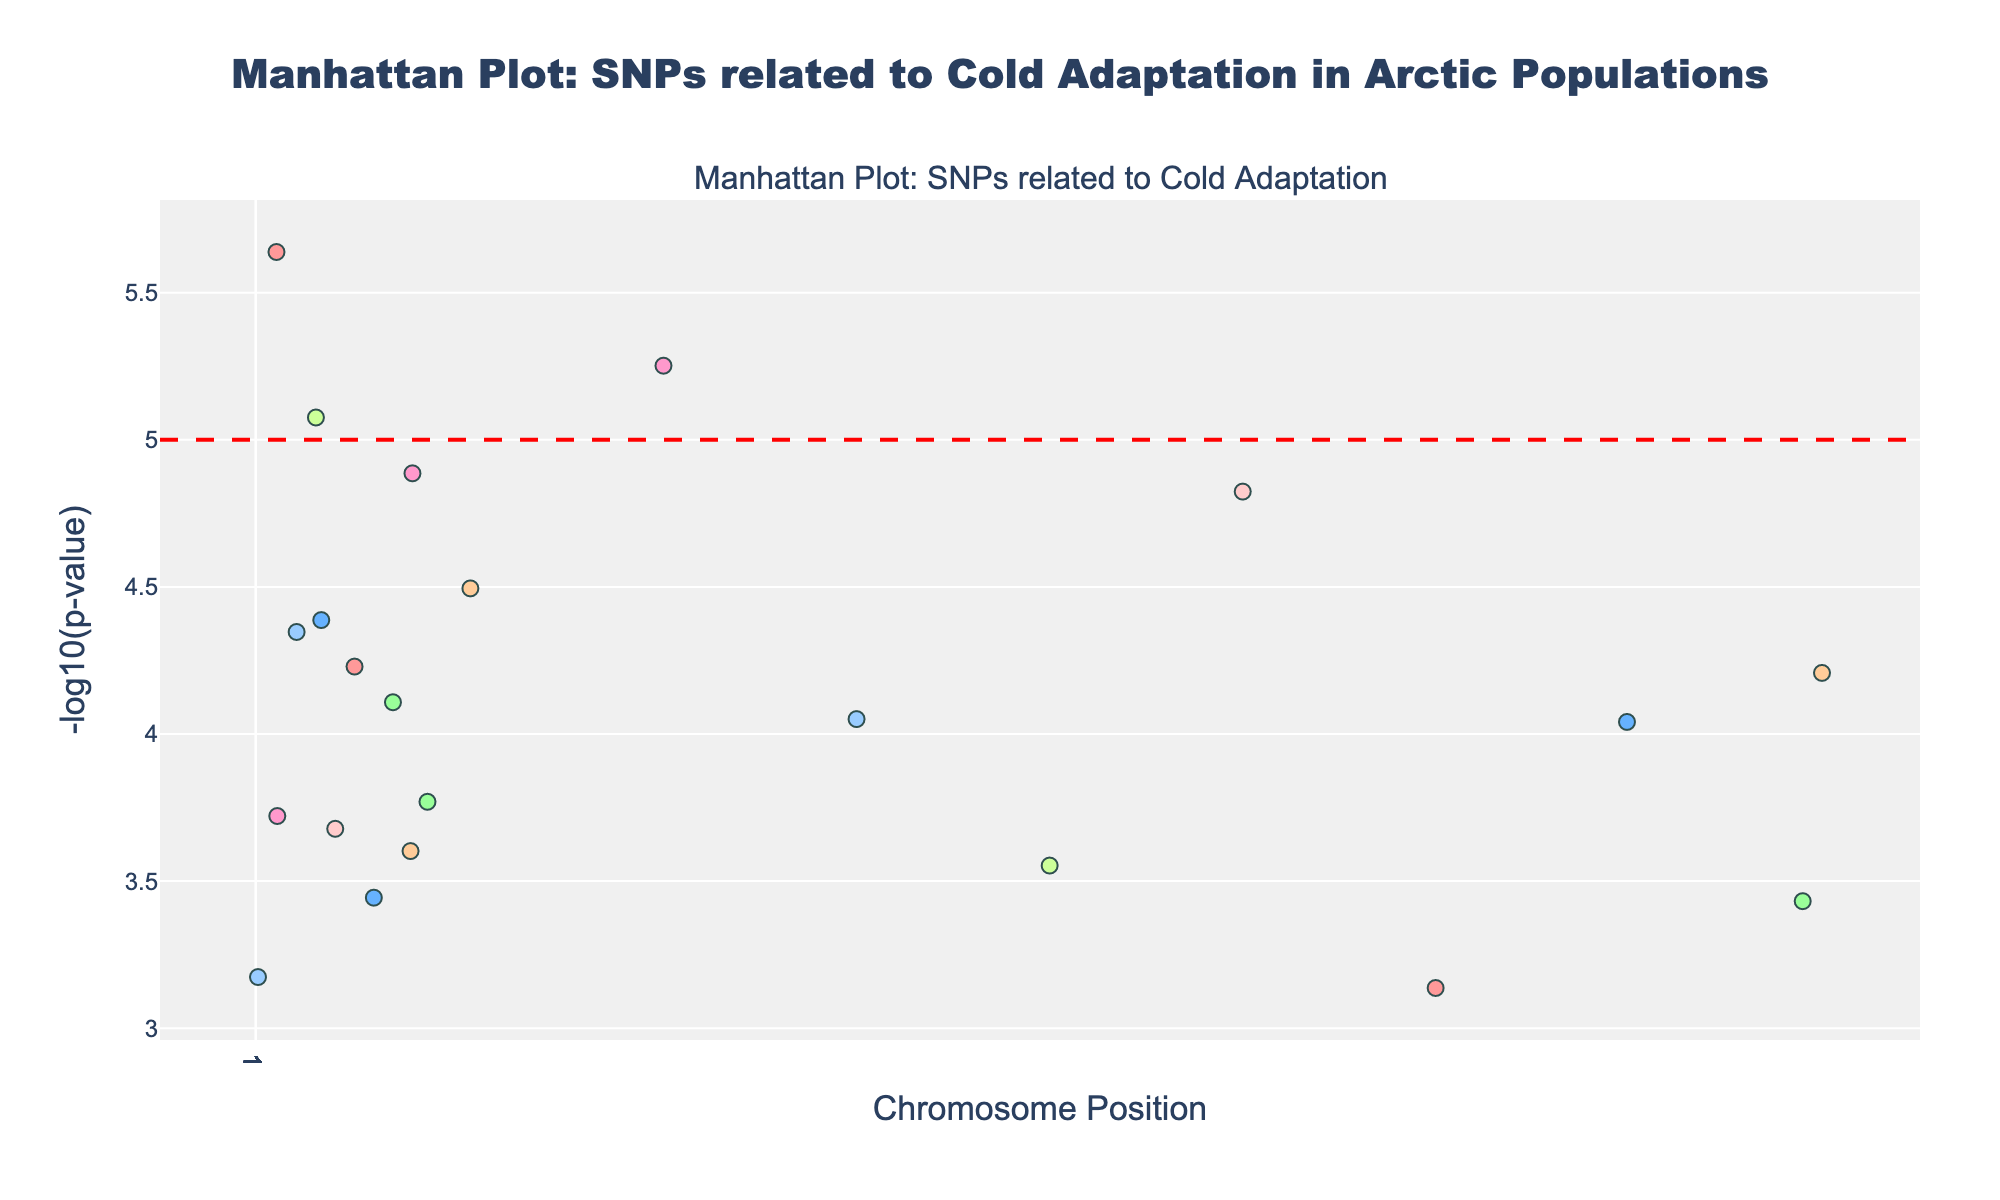Which chromosome has the SNP with the lowest p-value? The Manhattan Plot shows different chromosomes with their corresponding SNPs and p-values. The one with the highest -log10(p-value) will be the SNP with the lowest p-value. By observing this, we can see the highest point on the chart.
Answer: Chromosome 1 How many SNPs are plotted in total? Counting the entire set of data points on the plot will give the total number of SNPs included in the Manhattan Plot.
Answer: 22 Which chromosome has the most significant number of SNPs? To identify this, observe the plot and count the number of SNPs (data points) in each chromosome. The chromosome with the highest count of points will have the most significant number of SNPs.
Answer: Chromosome 6 Are there any SNPs crossing the threshold line of -log10(p-value) = 5? Check for any points in the plot that are above the red threshold line of -log10(p-value) = 5. This will indicate if any SNPs have a p-value lower than 1e-5.
Answer: Yes What is the y-axis representing? The y-axis in a Manhattan Plot typically represents the significance level of each SNP's association, here displayed as -log10(p-value).
Answer: -log10(p-value) Which gene is associated with the SNP having the lowest p-value? Identify the SNP with the lowest p-value (highest -log10(p-value)) and refer to its corresponding gene label. In this dataset, it corresponds to a specific SNP listed with its gene.
Answer: CLCNKA Which chromosome shows the least significant SNP in terms of -log10(p-value)? Observing the data points on the plot, locate the one with the lowest -log10(p-value), which will be the least significant SNP, and identify its chromosome.
Answer: Chromosome 22 Is there more than one SNP associated with the same gene? If so, which gene? By examining the labels on the plot, look for any repetitions of gene names to find if more than one SNP is associated with the same gene.
Answer: Yes, ADRB2 and PPARG How many chromosomes have SNPs below the threshold line of -log10(p-value) = 5? Calculate how many distinct chromosomes have at least one SNP below the significance threshold by checking below the red line for each chromosome.
Answer: 22 Which gene is associated with the second most significant SNP? Find the SNP with the second highest -log10(p-value) and refer to its associated gene in the dataset or by its tooltip information on the plot.
Answer: PPARG 